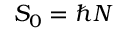<formula> <loc_0><loc_0><loc_500><loc_500>S _ { 0 } = \hbar { N }</formula> 